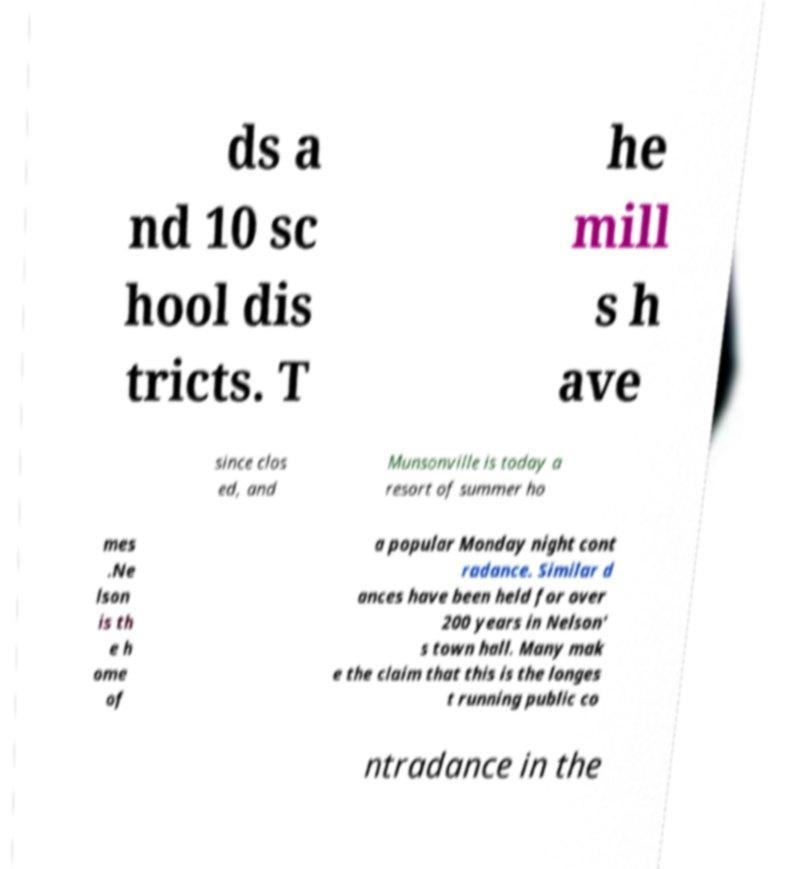Please identify and transcribe the text found in this image. ds a nd 10 sc hool dis tricts. T he mill s h ave since clos ed, and Munsonville is today a resort of summer ho mes .Ne lson is th e h ome of a popular Monday night cont radance. Similar d ances have been held for over 200 years in Nelson' s town hall. Many mak e the claim that this is the longes t running public co ntradance in the 